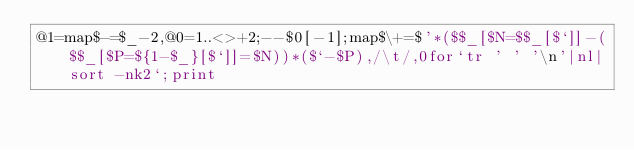Convert code to text. <code><loc_0><loc_0><loc_500><loc_500><_Perl_>@1=map$-=$_-2,@0=1..<>+2;--$0[-1];map$\+=$'*($$_[$N=$$_[$`]]-($$_[$P=${1-$_}[$`]]=$N))*($`-$P),/\t/,0for`tr ' ' '\n'|nl|sort -nk2`;print</code> 